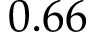Convert formula to latex. <formula><loc_0><loc_0><loc_500><loc_500>0 . 6 6</formula> 